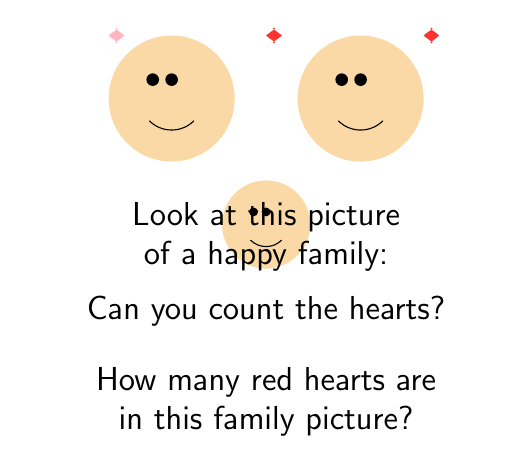Can you solve this math problem? Let's count the hearts together:

1. First, we can see there are three hearts in total above the family members.
2. Two of these hearts are red, and one is pink.
3. To count only the red hearts, we need to:
   - Look at each heart
   - Remember the color red
   - Count only the red ones

4. Starting from the left:
   - The first heart is pink, so we don't count it
   - The second heart in the middle is red, so we count it: $1$
   - The third heart on the right is also red, so we count it too: $1 + 1 = 2$

5. In total, we counted $2$ red hearts.

Remember, it's okay if counting feels a bit scary at first. You can always ask for help or take your time to count slowly.
Answer: $2$ 